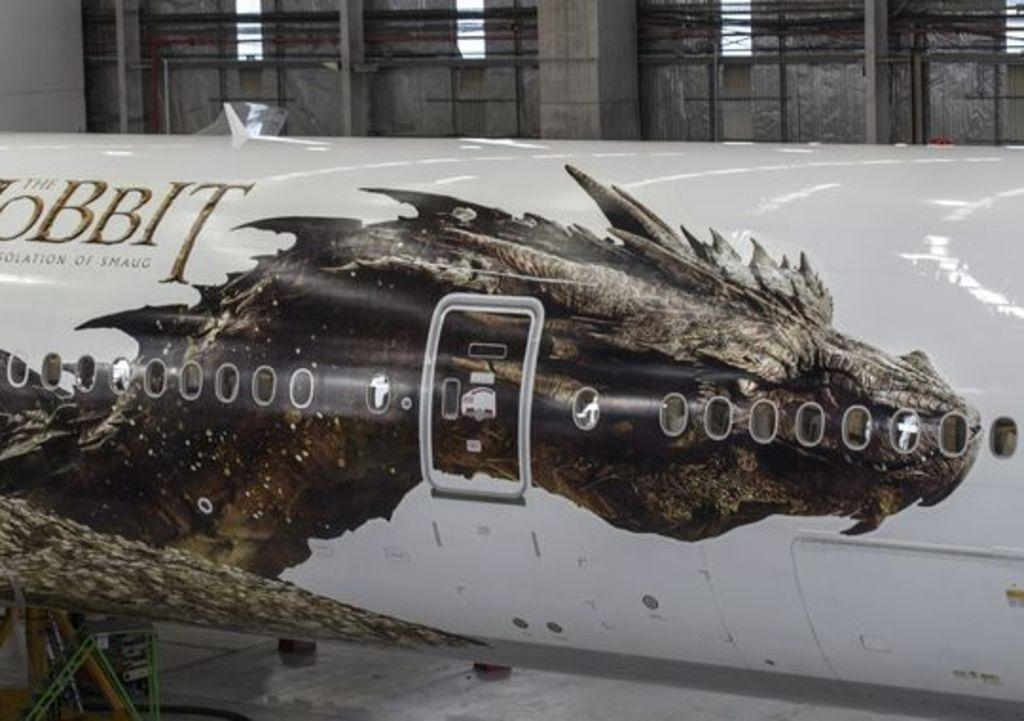What is the main subject of the image? The main subject of the image is an airplane. What can be seen on the left side of the image? There is some text on the left side of the image. What is visible in the background of the image? There is a wall in the background of the image. Can you describe the wall in the image? There is a door visible in the middle of the wall. What type of drink is being served from the airplane's stomach in the image? There is no mention of an airplane's stomach or any drinks being served in the image. 